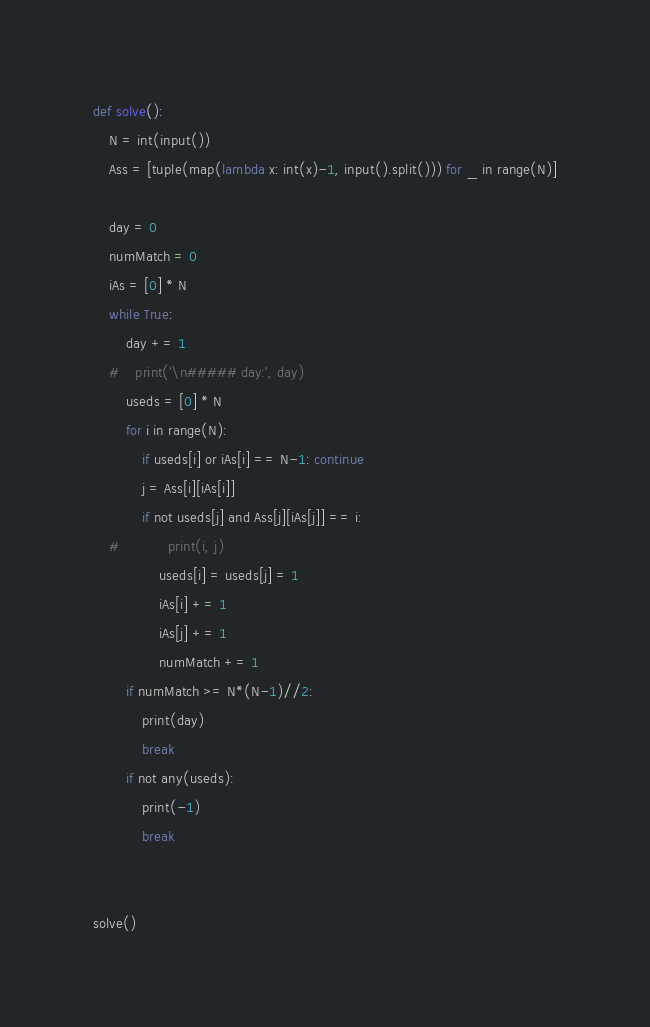<code> <loc_0><loc_0><loc_500><loc_500><_Python_>def solve():
    N = int(input())
    Ass = [tuple(map(lambda x: int(x)-1, input().split())) for _ in range(N)]

    day = 0
    numMatch = 0
    iAs = [0] * N
    while True:
        day += 1
    #    print('\n##### day:', day)
        useds = [0] * N
        for i in range(N):
            if useds[i] or iAs[i] == N-1: continue
            j = Ass[i][iAs[i]]
            if not useds[j] and Ass[j][iAs[j]] == i:
    #            print(i, j)
                useds[i] = useds[j] = 1
                iAs[i] += 1
                iAs[j] += 1
                numMatch += 1
        if numMatch >= N*(N-1)//2:
            print(day)
            break
        if not any(useds):
            print(-1)
            break


solve()
</code> 